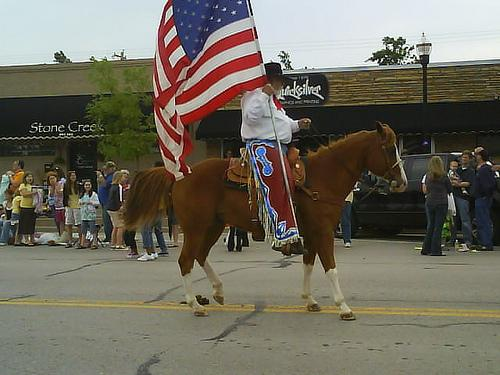What are the white marks on the horse's legs called? socks 